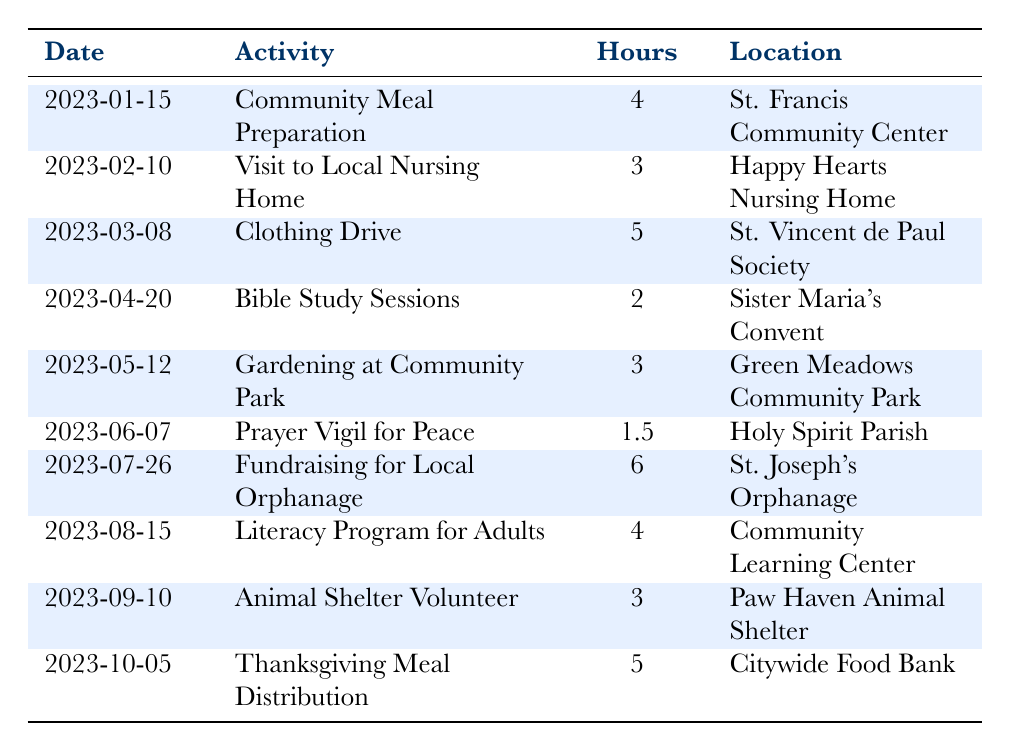What activity took place on February 10, 2023? The date of February 10, 2023, corresponds to the activity titled "Visit to Local Nursing Home" as listed in the table.
Answer: Visit to Local Nursing Home How many hours were spent on the "Fundraising for Local Orphanage" activity? By locating the row for "Fundraising for Local Orphanage," we see that the number of hours logged for this activity is 6.
Answer: 6 What is the total number of hours dedicated to volunteer service across all activities? To find the total hours, we sum all the hours: 4 + 3 + 5 + 2 + 3 + 1.5 + 6 + 4 + 3 + 5 = 36.5 hours.
Answer: 36.5 Were any activities conducted in the month of May? Checking the table, we see that there was an activity, "Gardening at Community Park," conducted on May 12, 2023, which confirms that an activity took place in May.
Answer: Yes What was the average number of hours spent per activity? First, we calculate the total hours which is 36.5 from the previous question. Since there are 10 activities, we compute the average as 36.5 / 10 = 3.65 hours.
Answer: 3.65 Which location had the least number of hours recorded for an activity? Analyzing the table, the "Prayer Vigil for Peace" on June 7 recorded 1.5 hours, which is less than the others listed.
Answer: Holy Spirit Parish How many activities involved teaching or educational components? Reviewing the table, there are two activities that focus on teaching: "Bible Study Sessions" and "Literacy Program for Adults," making the count 2.
Answer: 2 What activity had the highest volunteer hours? From the table, the activity with the highest recorded hours is "Fundraising for Local Orphanage" with 6 hours.
Answer: Fundraising for Local Orphanage Which month had the most volunteer hours? Calculating the hours by month: January (4), February (3), March (5), April (2), May (3), June (1.5), July (6), August (4), September (3), October (5). The highest total is from July with 6 hours.
Answer: July 